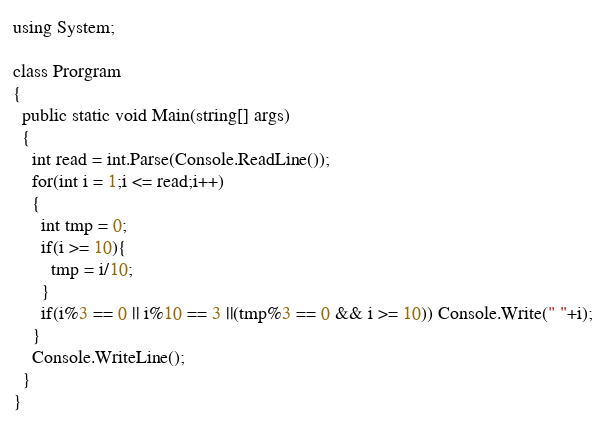<code> <loc_0><loc_0><loc_500><loc_500><_C#_>using System;

class Prorgram
{
  public static void Main(string[] args)
  {
    int read = int.Parse(Console.ReadLine());
    for(int i = 1;i <= read;i++)
    {
      int tmp = 0;
      if(i >= 10){
        tmp = i/10;
      }
      if(i%3 == 0 || i%10 == 3 ||(tmp%3 == 0 && i >= 10)) Console.Write(" "+i);
    }
    Console.WriteLine();
  }
}</code> 